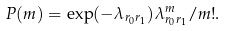<formula> <loc_0><loc_0><loc_500><loc_500>P ( m ) = \exp ( - \lambda _ { r _ { 0 } r _ { 1 } } ) \lambda _ { r _ { 0 } r _ { 1 } } ^ { m } / m ! .</formula> 